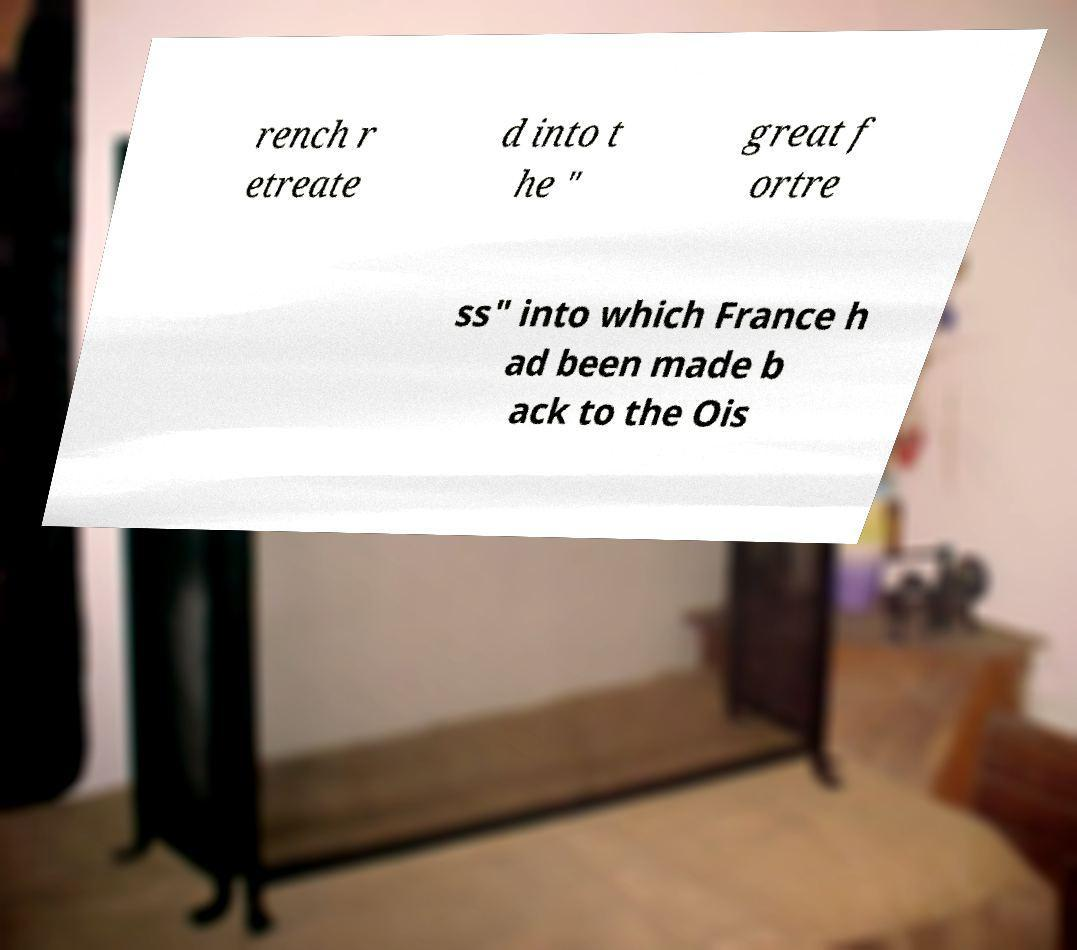Please read and relay the text visible in this image. What does it say? rench r etreate d into t he " great f ortre ss" into which France h ad been made b ack to the Ois 